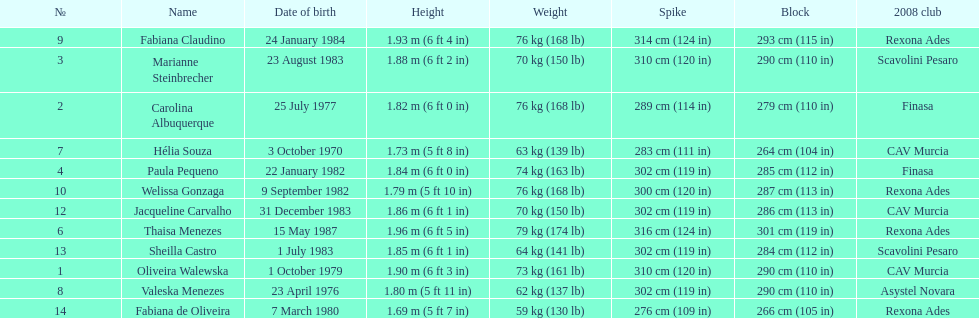Could you parse the entire table? {'header': ['№', 'Name', 'Date of birth', 'Height', 'Weight', 'Spike', 'Block', '2008 club'], 'rows': [['9', 'Fabiana Claudino', '24 January 1984', '1.93\xa0m (6\xa0ft 4\xa0in)', '76\xa0kg (168\xa0lb)', '314\xa0cm (124\xa0in)', '293\xa0cm (115\xa0in)', 'Rexona Ades'], ['3', 'Marianne Steinbrecher', '23 August 1983', '1.88\xa0m (6\xa0ft 2\xa0in)', '70\xa0kg (150\xa0lb)', '310\xa0cm (120\xa0in)', '290\xa0cm (110\xa0in)', 'Scavolini Pesaro'], ['2', 'Carolina Albuquerque', '25 July 1977', '1.82\xa0m (6\xa0ft 0\xa0in)', '76\xa0kg (168\xa0lb)', '289\xa0cm (114\xa0in)', '279\xa0cm (110\xa0in)', 'Finasa'], ['7', 'Hélia Souza', '3 October 1970', '1.73\xa0m (5\xa0ft 8\xa0in)', '63\xa0kg (139\xa0lb)', '283\xa0cm (111\xa0in)', '264\xa0cm (104\xa0in)', 'CAV Murcia'], ['4', 'Paula Pequeno', '22 January 1982', '1.84\xa0m (6\xa0ft 0\xa0in)', '74\xa0kg (163\xa0lb)', '302\xa0cm (119\xa0in)', '285\xa0cm (112\xa0in)', 'Finasa'], ['10', 'Welissa Gonzaga', '9 September 1982', '1.79\xa0m (5\xa0ft 10\xa0in)', '76\xa0kg (168\xa0lb)', '300\xa0cm (120\xa0in)', '287\xa0cm (113\xa0in)', 'Rexona Ades'], ['12', 'Jacqueline Carvalho', '31 December 1983', '1.86\xa0m (6\xa0ft 1\xa0in)', '70\xa0kg (150\xa0lb)', '302\xa0cm (119\xa0in)', '286\xa0cm (113\xa0in)', 'CAV Murcia'], ['6', 'Thaisa Menezes', '15 May 1987', '1.96\xa0m (6\xa0ft 5\xa0in)', '79\xa0kg (174\xa0lb)', '316\xa0cm (124\xa0in)', '301\xa0cm (119\xa0in)', 'Rexona Ades'], ['13', 'Sheilla Castro', '1 July 1983', '1.85\xa0m (6\xa0ft 1\xa0in)', '64\xa0kg (141\xa0lb)', '302\xa0cm (119\xa0in)', '284\xa0cm (112\xa0in)', 'Scavolini Pesaro'], ['1', 'Oliveira Walewska', '1 October 1979', '1.90\xa0m (6\xa0ft 3\xa0in)', '73\xa0kg (161\xa0lb)', '310\xa0cm (120\xa0in)', '290\xa0cm (110\xa0in)', 'CAV Murcia'], ['8', 'Valeska Menezes', '23 April 1976', '1.80\xa0m (5\xa0ft 11\xa0in)', '62\xa0kg (137\xa0lb)', '302\xa0cm (119\xa0in)', '290\xa0cm (110\xa0in)', 'Asystel Novara'], ['14', 'Fabiana de Oliveira', '7 March 1980', '1.69\xa0m (5\xa0ft 7\xa0in)', '59\xa0kg (130\xa0lb)', '276\xa0cm (109\xa0in)', '266\xa0cm (105\xa0in)', 'Rexona Ades']]} Which player is the shortest at only 5 ft 7 in? Fabiana de Oliveira. 